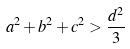<formula> <loc_0><loc_0><loc_500><loc_500>a ^ { 2 } + b ^ { 2 } + c ^ { 2 } > \frac { d ^ { 2 } } { 3 }</formula> 